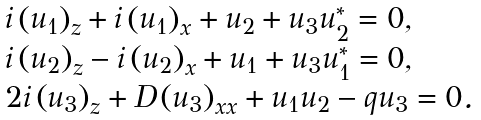<formula> <loc_0><loc_0><loc_500><loc_500>\begin{array} { l } i \left ( u _ { 1 } \right ) _ { z } + i \left ( u _ { 1 } \right ) _ { x } + u _ { 2 } + u _ { 3 } u _ { 2 } ^ { \ast } = 0 , \\ i \left ( u _ { 2 } \right ) _ { z } - i \left ( u _ { 2 } \right ) _ { x } + u _ { 1 } + u _ { 3 } u _ { 1 } ^ { \ast } = 0 , \\ 2 i \left ( u _ { 3 } \right ) _ { z } + D \left ( u _ { 3 } \right ) _ { x x } + u _ { 1 } u _ { 2 } - q u _ { 3 } = 0 . \end{array}</formula> 